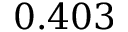<formula> <loc_0><loc_0><loc_500><loc_500>0 . 4 0 3</formula> 